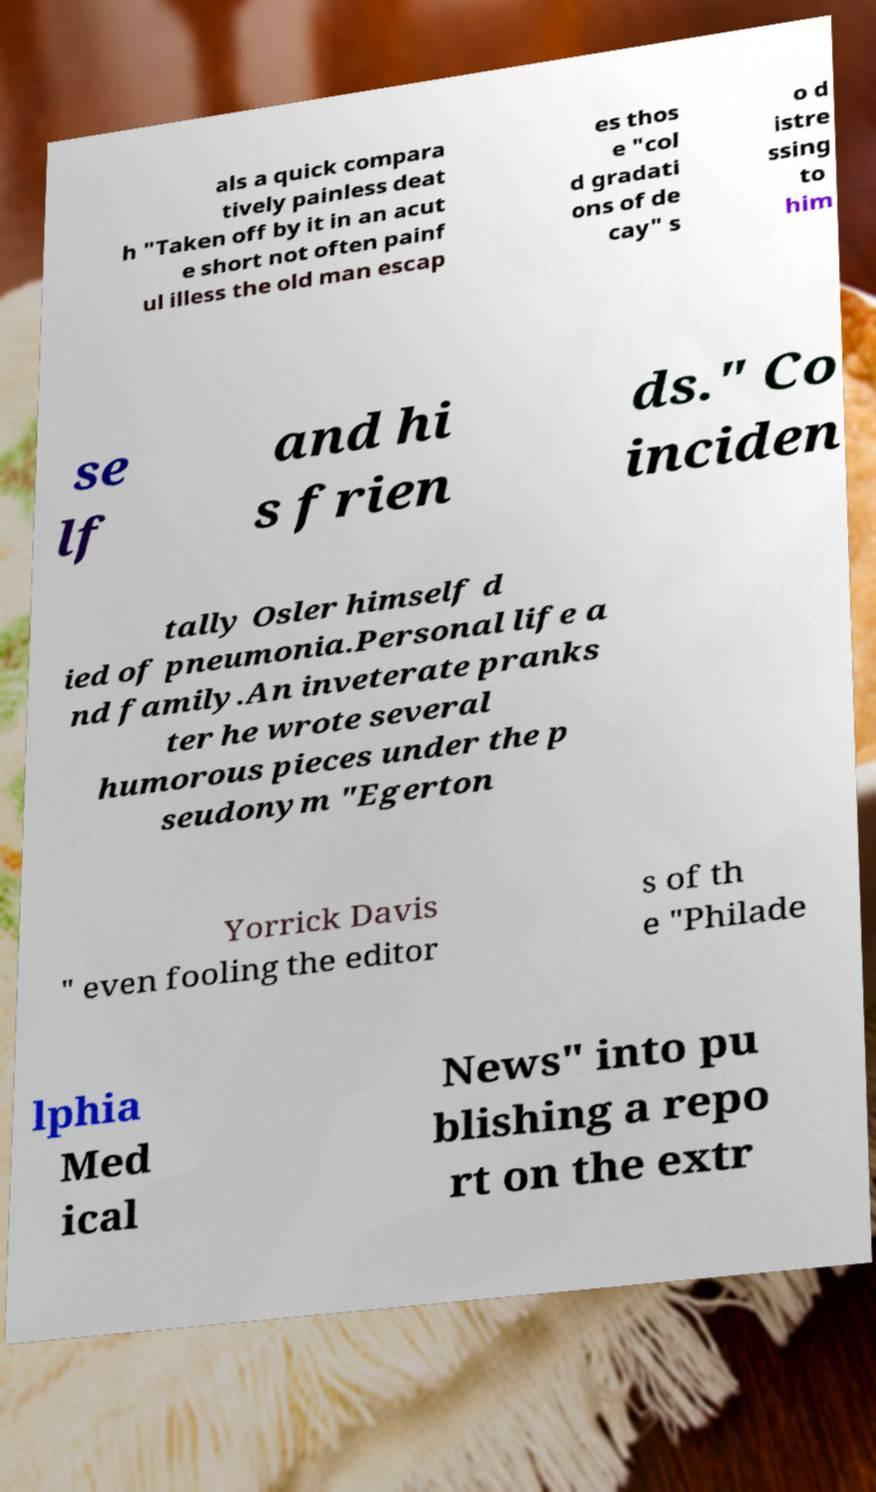What messages or text are displayed in this image? I need them in a readable, typed format. als a quick compara tively painless deat h "Taken off by it in an acut e short not often painf ul illess the old man escap es thos e "col d gradati ons of de cay" s o d istre ssing to him se lf and hi s frien ds." Co inciden tally Osler himself d ied of pneumonia.Personal life a nd family.An inveterate pranks ter he wrote several humorous pieces under the p seudonym "Egerton Yorrick Davis " even fooling the editor s of th e "Philade lphia Med ical News" into pu blishing a repo rt on the extr 